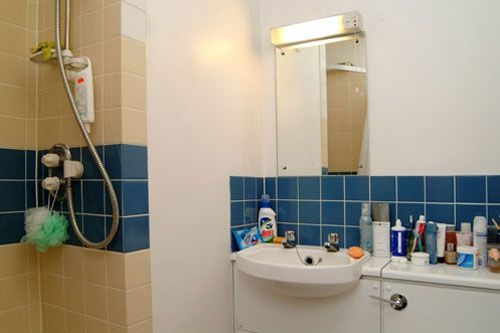Describe the objects in this image and their specific colors. I can see toilet in tan, darkgray, gray, and black tones, sink in tan, lightgray, and darkgray tones, toothbrush in tan, teal, gray, and black tones, and toothbrush in tan, blue, black, and gray tones in this image. 